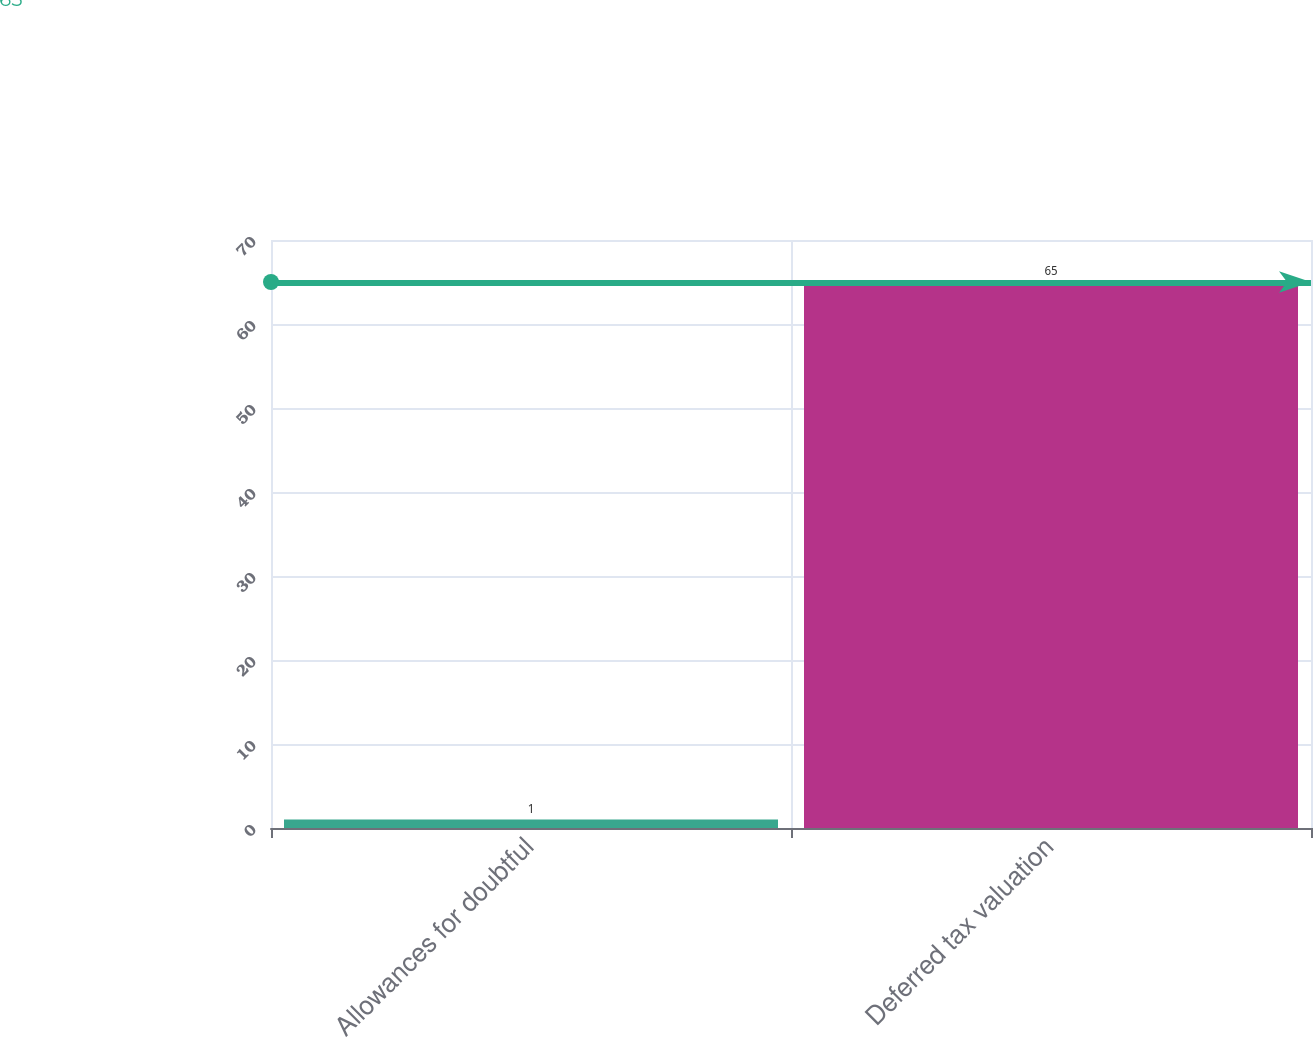Convert chart. <chart><loc_0><loc_0><loc_500><loc_500><bar_chart><fcel>Allowances for doubtful<fcel>Deferred tax valuation<nl><fcel>1<fcel>65<nl></chart> 